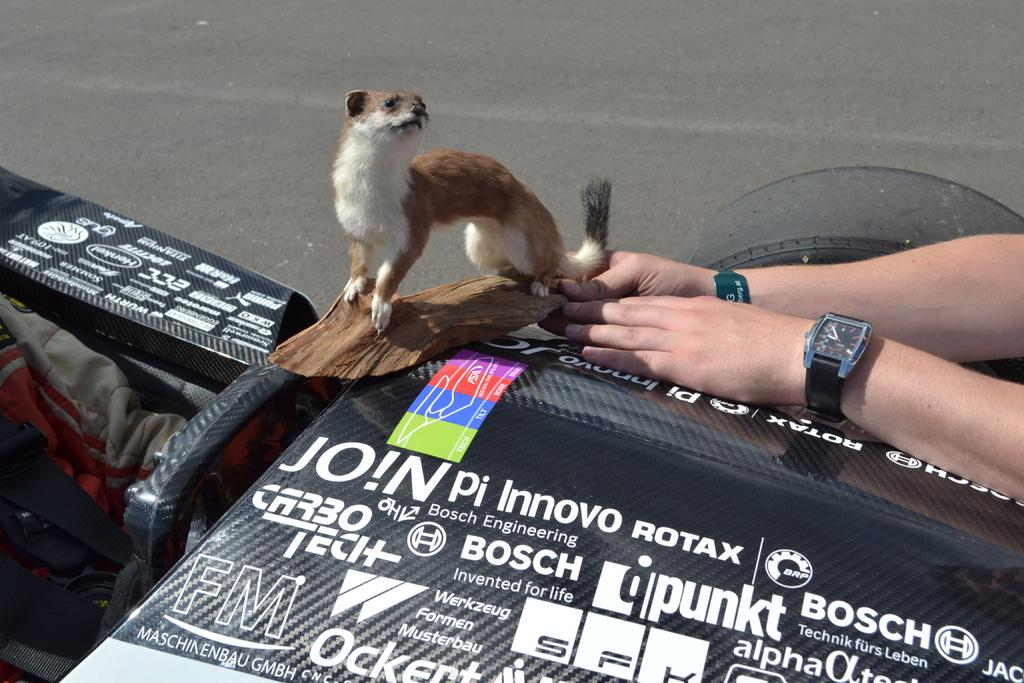What type of animal is in the image? There is an animal in the image, but the specific type cannot be determined from the provided facts. What is the animal standing on? The animal is on a piece of wood block. What is another object visible in the image? There is a wristwatch in the image. What type of surface can be seen in the image? There is a road in the image. Whose hands are visible in the image? Human hands are visible in the image. What else can be seen in the image that contains words? There is text in the image. How many rabbits are sitting on the spoon in the image? There is no spoon or rabbits present in the image. What color is the tongue of the animal in the image? The specific type of animal and its tongue color cannot be determined from the provided facts. 